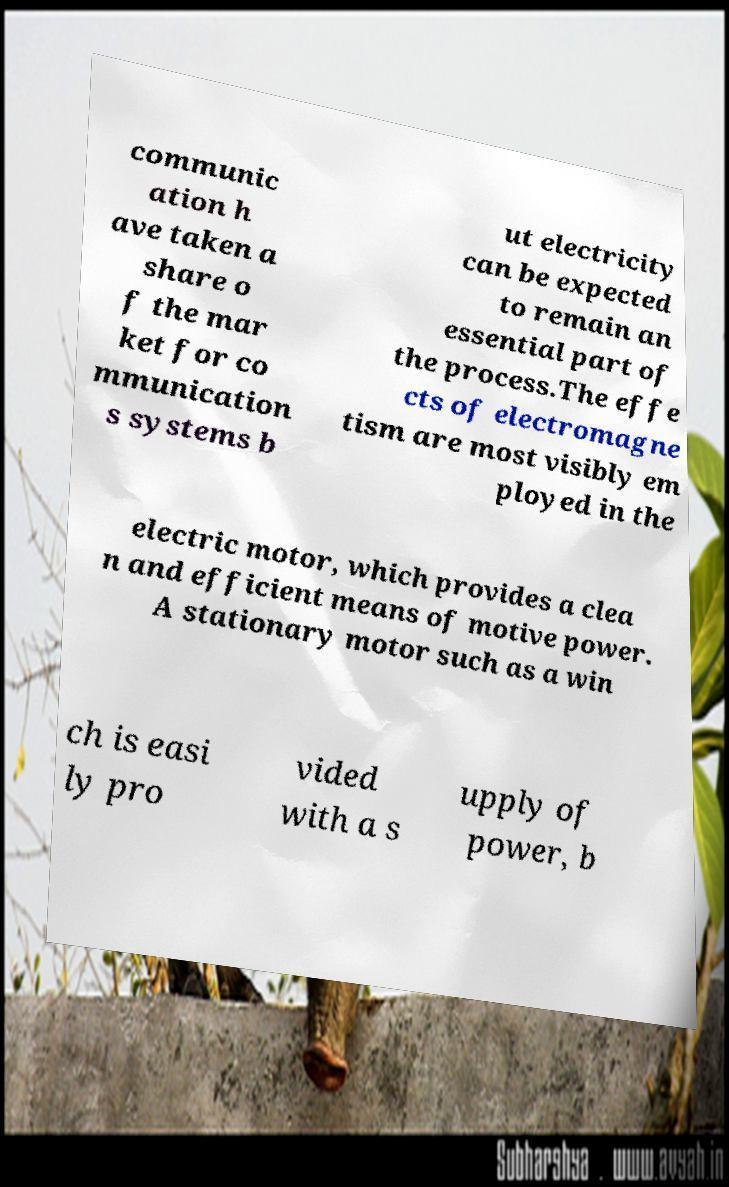There's text embedded in this image that I need extracted. Can you transcribe it verbatim? communic ation h ave taken a share o f the mar ket for co mmunication s systems b ut electricity can be expected to remain an essential part of the process.The effe cts of electromagne tism are most visibly em ployed in the electric motor, which provides a clea n and efficient means of motive power. A stationary motor such as a win ch is easi ly pro vided with a s upply of power, b 